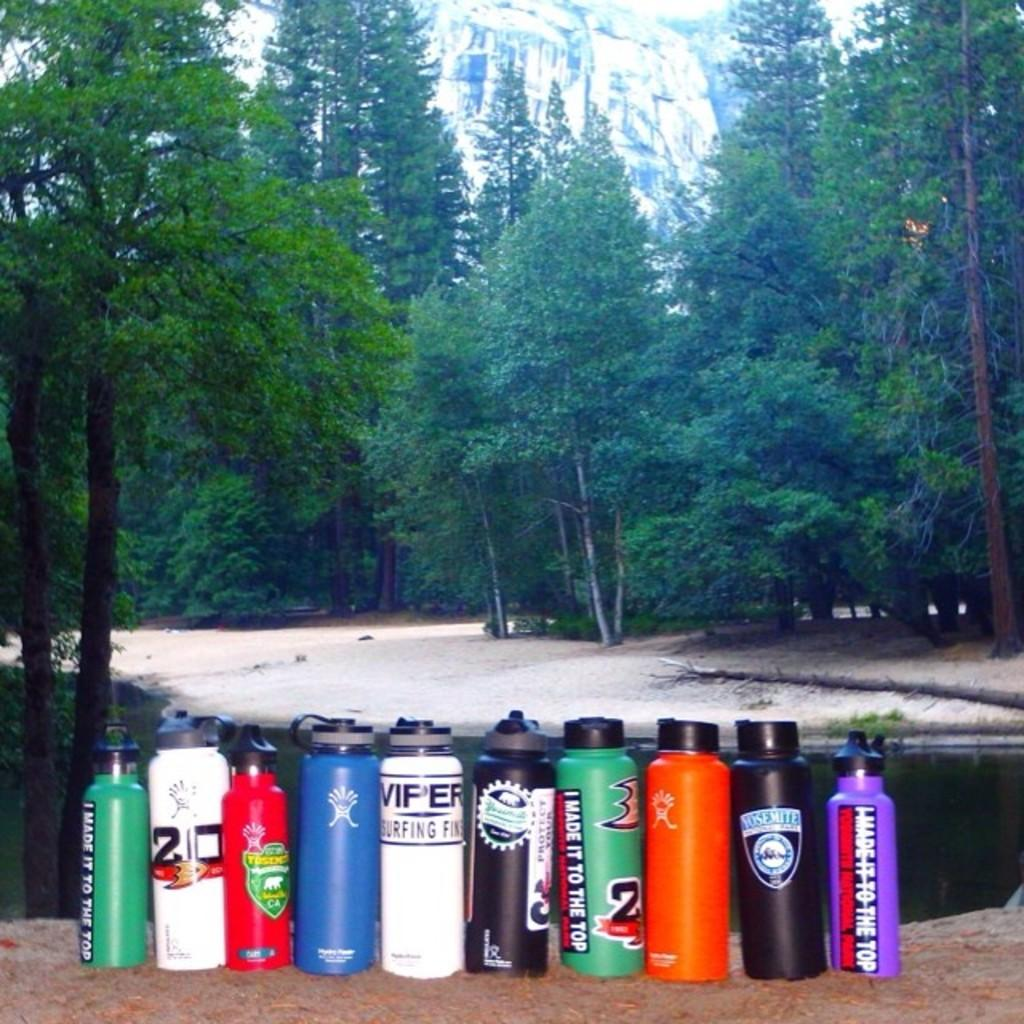What objects can be seen in the image? There are bottles in the image. What type of natural environment is visible in the image? There are trees and hills visible in the image. How many representatives are present in the image? There are no representatives present in the image; it features bottles and a natural environment. 